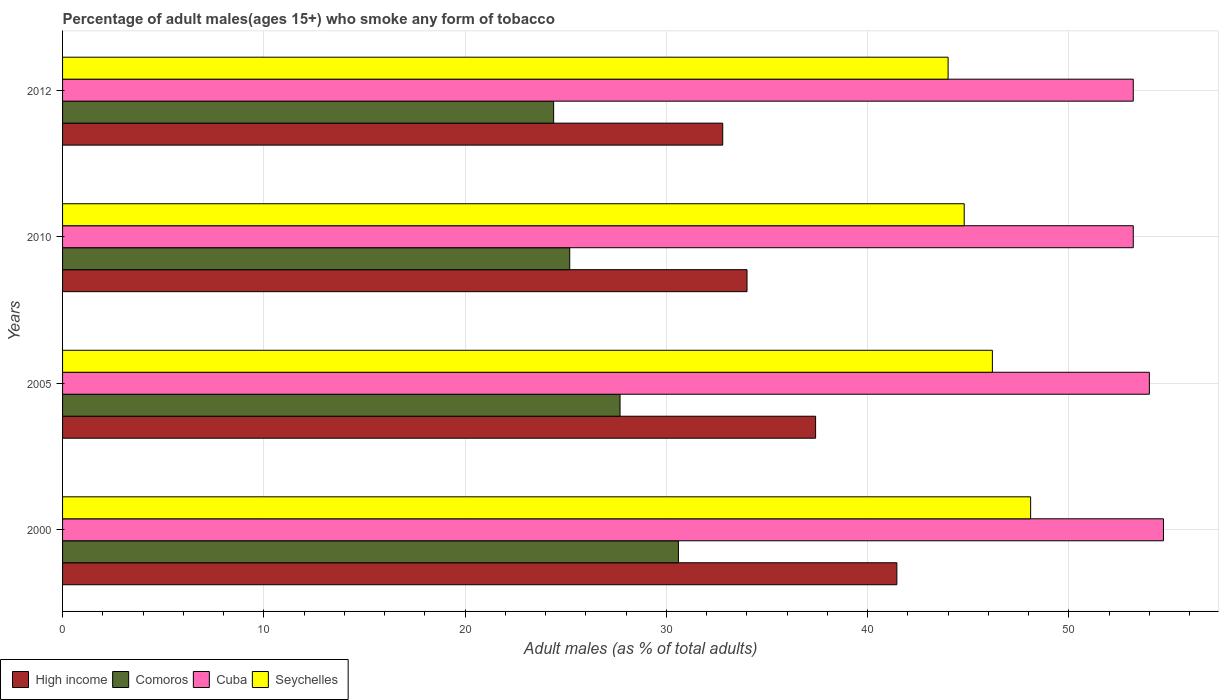How many different coloured bars are there?
Keep it short and to the point. 4. How many groups of bars are there?
Your response must be concise. 4. Are the number of bars per tick equal to the number of legend labels?
Provide a short and direct response. Yes. Are the number of bars on each tick of the Y-axis equal?
Offer a terse response. Yes. How many bars are there on the 2nd tick from the bottom?
Provide a succinct answer. 4. What is the label of the 3rd group of bars from the top?
Offer a terse response. 2005. In how many cases, is the number of bars for a given year not equal to the number of legend labels?
Provide a succinct answer. 0. What is the percentage of adult males who smoke in Seychelles in 2005?
Ensure brevity in your answer.  46.2. Across all years, what is the maximum percentage of adult males who smoke in Cuba?
Make the answer very short. 54.7. In which year was the percentage of adult males who smoke in Cuba maximum?
Offer a very short reply. 2000. What is the total percentage of adult males who smoke in High income in the graph?
Make the answer very short. 145.68. What is the difference between the percentage of adult males who smoke in Seychelles in 2000 and that in 2005?
Your answer should be compact. 1.9. What is the difference between the percentage of adult males who smoke in High income in 2005 and the percentage of adult males who smoke in Cuba in 2000?
Make the answer very short. -17.28. What is the average percentage of adult males who smoke in High income per year?
Your response must be concise. 36.42. In the year 2012, what is the difference between the percentage of adult males who smoke in High income and percentage of adult males who smoke in Comoros?
Your answer should be compact. 8.4. Is the percentage of adult males who smoke in High income in 2005 less than that in 2010?
Provide a short and direct response. No. Is the difference between the percentage of adult males who smoke in High income in 2000 and 2010 greater than the difference between the percentage of adult males who smoke in Comoros in 2000 and 2010?
Provide a succinct answer. Yes. What is the difference between the highest and the second highest percentage of adult males who smoke in Cuba?
Keep it short and to the point. 0.7. What is the difference between the highest and the lowest percentage of adult males who smoke in Comoros?
Ensure brevity in your answer.  6.2. What does the 3rd bar from the top in 2012 represents?
Offer a very short reply. Comoros. What does the 3rd bar from the bottom in 2012 represents?
Give a very brief answer. Cuba. Is it the case that in every year, the sum of the percentage of adult males who smoke in Comoros and percentage of adult males who smoke in Seychelles is greater than the percentage of adult males who smoke in High income?
Your answer should be compact. Yes. Are the values on the major ticks of X-axis written in scientific E-notation?
Give a very brief answer. No. Does the graph contain any zero values?
Your response must be concise. No. Where does the legend appear in the graph?
Your response must be concise. Bottom left. How many legend labels are there?
Keep it short and to the point. 4. What is the title of the graph?
Offer a terse response. Percentage of adult males(ages 15+) who smoke any form of tobacco. What is the label or title of the X-axis?
Your answer should be very brief. Adult males (as % of total adults). What is the Adult males (as % of total adults) of High income in 2000?
Keep it short and to the point. 41.45. What is the Adult males (as % of total adults) in Comoros in 2000?
Keep it short and to the point. 30.6. What is the Adult males (as % of total adults) of Cuba in 2000?
Offer a terse response. 54.7. What is the Adult males (as % of total adults) in Seychelles in 2000?
Your answer should be compact. 48.1. What is the Adult males (as % of total adults) in High income in 2005?
Provide a short and direct response. 37.42. What is the Adult males (as % of total adults) in Comoros in 2005?
Ensure brevity in your answer.  27.7. What is the Adult males (as % of total adults) of Cuba in 2005?
Give a very brief answer. 54. What is the Adult males (as % of total adults) of Seychelles in 2005?
Ensure brevity in your answer.  46.2. What is the Adult males (as % of total adults) in High income in 2010?
Make the answer very short. 34.01. What is the Adult males (as % of total adults) in Comoros in 2010?
Give a very brief answer. 25.2. What is the Adult males (as % of total adults) in Cuba in 2010?
Offer a very short reply. 53.2. What is the Adult males (as % of total adults) in Seychelles in 2010?
Your answer should be compact. 44.8. What is the Adult males (as % of total adults) in High income in 2012?
Your response must be concise. 32.8. What is the Adult males (as % of total adults) of Comoros in 2012?
Offer a terse response. 24.4. What is the Adult males (as % of total adults) of Cuba in 2012?
Provide a short and direct response. 53.2. What is the Adult males (as % of total adults) of Seychelles in 2012?
Offer a very short reply. 44. Across all years, what is the maximum Adult males (as % of total adults) in High income?
Ensure brevity in your answer.  41.45. Across all years, what is the maximum Adult males (as % of total adults) of Comoros?
Keep it short and to the point. 30.6. Across all years, what is the maximum Adult males (as % of total adults) of Cuba?
Offer a terse response. 54.7. Across all years, what is the maximum Adult males (as % of total adults) of Seychelles?
Make the answer very short. 48.1. Across all years, what is the minimum Adult males (as % of total adults) of High income?
Offer a terse response. 32.8. Across all years, what is the minimum Adult males (as % of total adults) of Comoros?
Provide a short and direct response. 24.4. Across all years, what is the minimum Adult males (as % of total adults) of Cuba?
Your answer should be compact. 53.2. Across all years, what is the minimum Adult males (as % of total adults) of Seychelles?
Give a very brief answer. 44. What is the total Adult males (as % of total adults) in High income in the graph?
Offer a very short reply. 145.68. What is the total Adult males (as % of total adults) of Comoros in the graph?
Give a very brief answer. 107.9. What is the total Adult males (as % of total adults) in Cuba in the graph?
Your answer should be very brief. 215.1. What is the total Adult males (as % of total adults) in Seychelles in the graph?
Your answer should be very brief. 183.1. What is the difference between the Adult males (as % of total adults) in High income in 2000 and that in 2005?
Make the answer very short. 4.04. What is the difference between the Adult males (as % of total adults) in Comoros in 2000 and that in 2005?
Give a very brief answer. 2.9. What is the difference between the Adult males (as % of total adults) in Seychelles in 2000 and that in 2005?
Ensure brevity in your answer.  1.9. What is the difference between the Adult males (as % of total adults) in High income in 2000 and that in 2010?
Your response must be concise. 7.45. What is the difference between the Adult males (as % of total adults) of Cuba in 2000 and that in 2010?
Your answer should be compact. 1.5. What is the difference between the Adult males (as % of total adults) of Seychelles in 2000 and that in 2010?
Offer a very short reply. 3.3. What is the difference between the Adult males (as % of total adults) in High income in 2000 and that in 2012?
Provide a short and direct response. 8.65. What is the difference between the Adult males (as % of total adults) of Comoros in 2000 and that in 2012?
Keep it short and to the point. 6.2. What is the difference between the Adult males (as % of total adults) in Cuba in 2000 and that in 2012?
Your answer should be compact. 1.5. What is the difference between the Adult males (as % of total adults) of High income in 2005 and that in 2010?
Offer a terse response. 3.41. What is the difference between the Adult males (as % of total adults) of Comoros in 2005 and that in 2010?
Provide a succinct answer. 2.5. What is the difference between the Adult males (as % of total adults) of Seychelles in 2005 and that in 2010?
Offer a terse response. 1.4. What is the difference between the Adult males (as % of total adults) in High income in 2005 and that in 2012?
Offer a terse response. 4.61. What is the difference between the Adult males (as % of total adults) of Cuba in 2005 and that in 2012?
Give a very brief answer. 0.8. What is the difference between the Adult males (as % of total adults) of Seychelles in 2005 and that in 2012?
Offer a terse response. 2.2. What is the difference between the Adult males (as % of total adults) in High income in 2010 and that in 2012?
Offer a terse response. 1.21. What is the difference between the Adult males (as % of total adults) in Seychelles in 2010 and that in 2012?
Give a very brief answer. 0.8. What is the difference between the Adult males (as % of total adults) of High income in 2000 and the Adult males (as % of total adults) of Comoros in 2005?
Ensure brevity in your answer.  13.75. What is the difference between the Adult males (as % of total adults) of High income in 2000 and the Adult males (as % of total adults) of Cuba in 2005?
Give a very brief answer. -12.55. What is the difference between the Adult males (as % of total adults) of High income in 2000 and the Adult males (as % of total adults) of Seychelles in 2005?
Ensure brevity in your answer.  -4.75. What is the difference between the Adult males (as % of total adults) in Comoros in 2000 and the Adult males (as % of total adults) in Cuba in 2005?
Offer a terse response. -23.4. What is the difference between the Adult males (as % of total adults) of Comoros in 2000 and the Adult males (as % of total adults) of Seychelles in 2005?
Provide a short and direct response. -15.6. What is the difference between the Adult males (as % of total adults) of High income in 2000 and the Adult males (as % of total adults) of Comoros in 2010?
Offer a terse response. 16.25. What is the difference between the Adult males (as % of total adults) of High income in 2000 and the Adult males (as % of total adults) of Cuba in 2010?
Ensure brevity in your answer.  -11.75. What is the difference between the Adult males (as % of total adults) in High income in 2000 and the Adult males (as % of total adults) in Seychelles in 2010?
Keep it short and to the point. -3.35. What is the difference between the Adult males (as % of total adults) of Comoros in 2000 and the Adult males (as % of total adults) of Cuba in 2010?
Ensure brevity in your answer.  -22.6. What is the difference between the Adult males (as % of total adults) in Cuba in 2000 and the Adult males (as % of total adults) in Seychelles in 2010?
Ensure brevity in your answer.  9.9. What is the difference between the Adult males (as % of total adults) in High income in 2000 and the Adult males (as % of total adults) in Comoros in 2012?
Provide a succinct answer. 17.05. What is the difference between the Adult males (as % of total adults) of High income in 2000 and the Adult males (as % of total adults) of Cuba in 2012?
Offer a terse response. -11.75. What is the difference between the Adult males (as % of total adults) in High income in 2000 and the Adult males (as % of total adults) in Seychelles in 2012?
Offer a terse response. -2.55. What is the difference between the Adult males (as % of total adults) in Comoros in 2000 and the Adult males (as % of total adults) in Cuba in 2012?
Your response must be concise. -22.6. What is the difference between the Adult males (as % of total adults) of Comoros in 2000 and the Adult males (as % of total adults) of Seychelles in 2012?
Give a very brief answer. -13.4. What is the difference between the Adult males (as % of total adults) of High income in 2005 and the Adult males (as % of total adults) of Comoros in 2010?
Ensure brevity in your answer.  12.22. What is the difference between the Adult males (as % of total adults) of High income in 2005 and the Adult males (as % of total adults) of Cuba in 2010?
Provide a short and direct response. -15.78. What is the difference between the Adult males (as % of total adults) in High income in 2005 and the Adult males (as % of total adults) in Seychelles in 2010?
Your response must be concise. -7.38. What is the difference between the Adult males (as % of total adults) of Comoros in 2005 and the Adult males (as % of total adults) of Cuba in 2010?
Ensure brevity in your answer.  -25.5. What is the difference between the Adult males (as % of total adults) in Comoros in 2005 and the Adult males (as % of total adults) in Seychelles in 2010?
Give a very brief answer. -17.1. What is the difference between the Adult males (as % of total adults) in Cuba in 2005 and the Adult males (as % of total adults) in Seychelles in 2010?
Ensure brevity in your answer.  9.2. What is the difference between the Adult males (as % of total adults) of High income in 2005 and the Adult males (as % of total adults) of Comoros in 2012?
Ensure brevity in your answer.  13.02. What is the difference between the Adult males (as % of total adults) of High income in 2005 and the Adult males (as % of total adults) of Cuba in 2012?
Make the answer very short. -15.78. What is the difference between the Adult males (as % of total adults) in High income in 2005 and the Adult males (as % of total adults) in Seychelles in 2012?
Provide a succinct answer. -6.58. What is the difference between the Adult males (as % of total adults) of Comoros in 2005 and the Adult males (as % of total adults) of Cuba in 2012?
Offer a very short reply. -25.5. What is the difference between the Adult males (as % of total adults) of Comoros in 2005 and the Adult males (as % of total adults) of Seychelles in 2012?
Make the answer very short. -16.3. What is the difference between the Adult males (as % of total adults) of High income in 2010 and the Adult males (as % of total adults) of Comoros in 2012?
Give a very brief answer. 9.61. What is the difference between the Adult males (as % of total adults) in High income in 2010 and the Adult males (as % of total adults) in Cuba in 2012?
Offer a terse response. -19.19. What is the difference between the Adult males (as % of total adults) of High income in 2010 and the Adult males (as % of total adults) of Seychelles in 2012?
Keep it short and to the point. -9.99. What is the difference between the Adult males (as % of total adults) of Comoros in 2010 and the Adult males (as % of total adults) of Seychelles in 2012?
Your answer should be very brief. -18.8. What is the average Adult males (as % of total adults) of High income per year?
Ensure brevity in your answer.  36.42. What is the average Adult males (as % of total adults) in Comoros per year?
Provide a short and direct response. 26.98. What is the average Adult males (as % of total adults) of Cuba per year?
Your answer should be compact. 53.77. What is the average Adult males (as % of total adults) in Seychelles per year?
Ensure brevity in your answer.  45.77. In the year 2000, what is the difference between the Adult males (as % of total adults) of High income and Adult males (as % of total adults) of Comoros?
Offer a terse response. 10.85. In the year 2000, what is the difference between the Adult males (as % of total adults) of High income and Adult males (as % of total adults) of Cuba?
Offer a very short reply. -13.25. In the year 2000, what is the difference between the Adult males (as % of total adults) in High income and Adult males (as % of total adults) in Seychelles?
Your answer should be very brief. -6.65. In the year 2000, what is the difference between the Adult males (as % of total adults) in Comoros and Adult males (as % of total adults) in Cuba?
Ensure brevity in your answer.  -24.1. In the year 2000, what is the difference between the Adult males (as % of total adults) of Comoros and Adult males (as % of total adults) of Seychelles?
Provide a short and direct response. -17.5. In the year 2000, what is the difference between the Adult males (as % of total adults) in Cuba and Adult males (as % of total adults) in Seychelles?
Your answer should be very brief. 6.6. In the year 2005, what is the difference between the Adult males (as % of total adults) of High income and Adult males (as % of total adults) of Comoros?
Offer a very short reply. 9.72. In the year 2005, what is the difference between the Adult males (as % of total adults) in High income and Adult males (as % of total adults) in Cuba?
Provide a succinct answer. -16.58. In the year 2005, what is the difference between the Adult males (as % of total adults) in High income and Adult males (as % of total adults) in Seychelles?
Your answer should be very brief. -8.78. In the year 2005, what is the difference between the Adult males (as % of total adults) in Comoros and Adult males (as % of total adults) in Cuba?
Make the answer very short. -26.3. In the year 2005, what is the difference between the Adult males (as % of total adults) in Comoros and Adult males (as % of total adults) in Seychelles?
Ensure brevity in your answer.  -18.5. In the year 2010, what is the difference between the Adult males (as % of total adults) of High income and Adult males (as % of total adults) of Comoros?
Keep it short and to the point. 8.81. In the year 2010, what is the difference between the Adult males (as % of total adults) of High income and Adult males (as % of total adults) of Cuba?
Keep it short and to the point. -19.19. In the year 2010, what is the difference between the Adult males (as % of total adults) in High income and Adult males (as % of total adults) in Seychelles?
Your answer should be very brief. -10.79. In the year 2010, what is the difference between the Adult males (as % of total adults) of Comoros and Adult males (as % of total adults) of Seychelles?
Provide a succinct answer. -19.6. In the year 2012, what is the difference between the Adult males (as % of total adults) in High income and Adult males (as % of total adults) in Comoros?
Offer a very short reply. 8.4. In the year 2012, what is the difference between the Adult males (as % of total adults) of High income and Adult males (as % of total adults) of Cuba?
Offer a terse response. -20.4. In the year 2012, what is the difference between the Adult males (as % of total adults) of High income and Adult males (as % of total adults) of Seychelles?
Offer a very short reply. -11.2. In the year 2012, what is the difference between the Adult males (as % of total adults) in Comoros and Adult males (as % of total adults) in Cuba?
Offer a terse response. -28.8. In the year 2012, what is the difference between the Adult males (as % of total adults) of Comoros and Adult males (as % of total adults) of Seychelles?
Your answer should be very brief. -19.6. What is the ratio of the Adult males (as % of total adults) of High income in 2000 to that in 2005?
Provide a short and direct response. 1.11. What is the ratio of the Adult males (as % of total adults) in Comoros in 2000 to that in 2005?
Offer a terse response. 1.1. What is the ratio of the Adult males (as % of total adults) in Cuba in 2000 to that in 2005?
Provide a short and direct response. 1.01. What is the ratio of the Adult males (as % of total adults) of Seychelles in 2000 to that in 2005?
Ensure brevity in your answer.  1.04. What is the ratio of the Adult males (as % of total adults) of High income in 2000 to that in 2010?
Make the answer very short. 1.22. What is the ratio of the Adult males (as % of total adults) in Comoros in 2000 to that in 2010?
Make the answer very short. 1.21. What is the ratio of the Adult males (as % of total adults) in Cuba in 2000 to that in 2010?
Make the answer very short. 1.03. What is the ratio of the Adult males (as % of total adults) of Seychelles in 2000 to that in 2010?
Ensure brevity in your answer.  1.07. What is the ratio of the Adult males (as % of total adults) in High income in 2000 to that in 2012?
Your answer should be very brief. 1.26. What is the ratio of the Adult males (as % of total adults) in Comoros in 2000 to that in 2012?
Your response must be concise. 1.25. What is the ratio of the Adult males (as % of total adults) of Cuba in 2000 to that in 2012?
Your answer should be compact. 1.03. What is the ratio of the Adult males (as % of total adults) in Seychelles in 2000 to that in 2012?
Your answer should be very brief. 1.09. What is the ratio of the Adult males (as % of total adults) in High income in 2005 to that in 2010?
Offer a very short reply. 1.1. What is the ratio of the Adult males (as % of total adults) in Comoros in 2005 to that in 2010?
Offer a very short reply. 1.1. What is the ratio of the Adult males (as % of total adults) of Cuba in 2005 to that in 2010?
Make the answer very short. 1.01. What is the ratio of the Adult males (as % of total adults) in Seychelles in 2005 to that in 2010?
Offer a terse response. 1.03. What is the ratio of the Adult males (as % of total adults) of High income in 2005 to that in 2012?
Ensure brevity in your answer.  1.14. What is the ratio of the Adult males (as % of total adults) in Comoros in 2005 to that in 2012?
Provide a short and direct response. 1.14. What is the ratio of the Adult males (as % of total adults) of Seychelles in 2005 to that in 2012?
Make the answer very short. 1.05. What is the ratio of the Adult males (as % of total adults) of High income in 2010 to that in 2012?
Your answer should be compact. 1.04. What is the ratio of the Adult males (as % of total adults) in Comoros in 2010 to that in 2012?
Your response must be concise. 1.03. What is the ratio of the Adult males (as % of total adults) of Cuba in 2010 to that in 2012?
Keep it short and to the point. 1. What is the ratio of the Adult males (as % of total adults) in Seychelles in 2010 to that in 2012?
Your answer should be very brief. 1.02. What is the difference between the highest and the second highest Adult males (as % of total adults) in High income?
Offer a very short reply. 4.04. What is the difference between the highest and the second highest Adult males (as % of total adults) of Seychelles?
Your response must be concise. 1.9. What is the difference between the highest and the lowest Adult males (as % of total adults) in High income?
Make the answer very short. 8.65. What is the difference between the highest and the lowest Adult males (as % of total adults) in Comoros?
Provide a short and direct response. 6.2. What is the difference between the highest and the lowest Adult males (as % of total adults) of Cuba?
Provide a short and direct response. 1.5. 